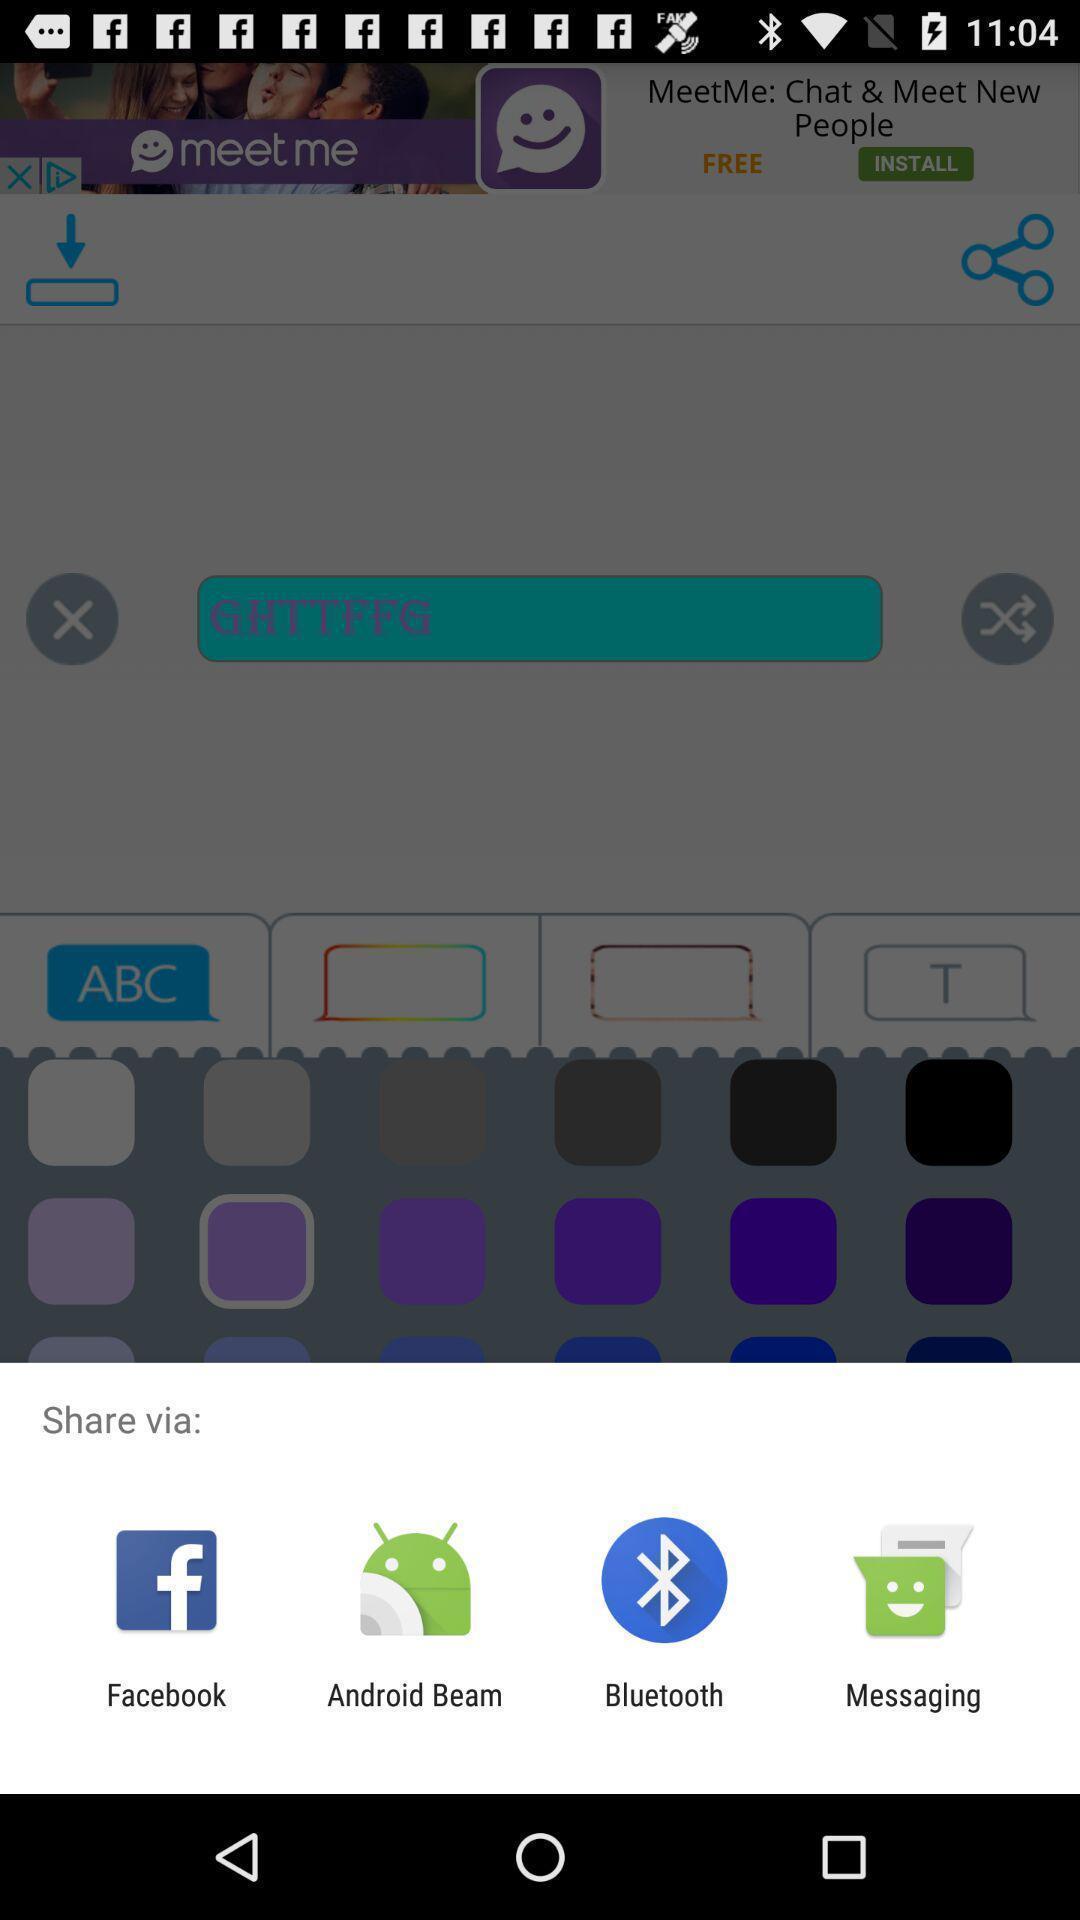Describe the visual elements of this screenshot. Pop-up to share using different apps. 